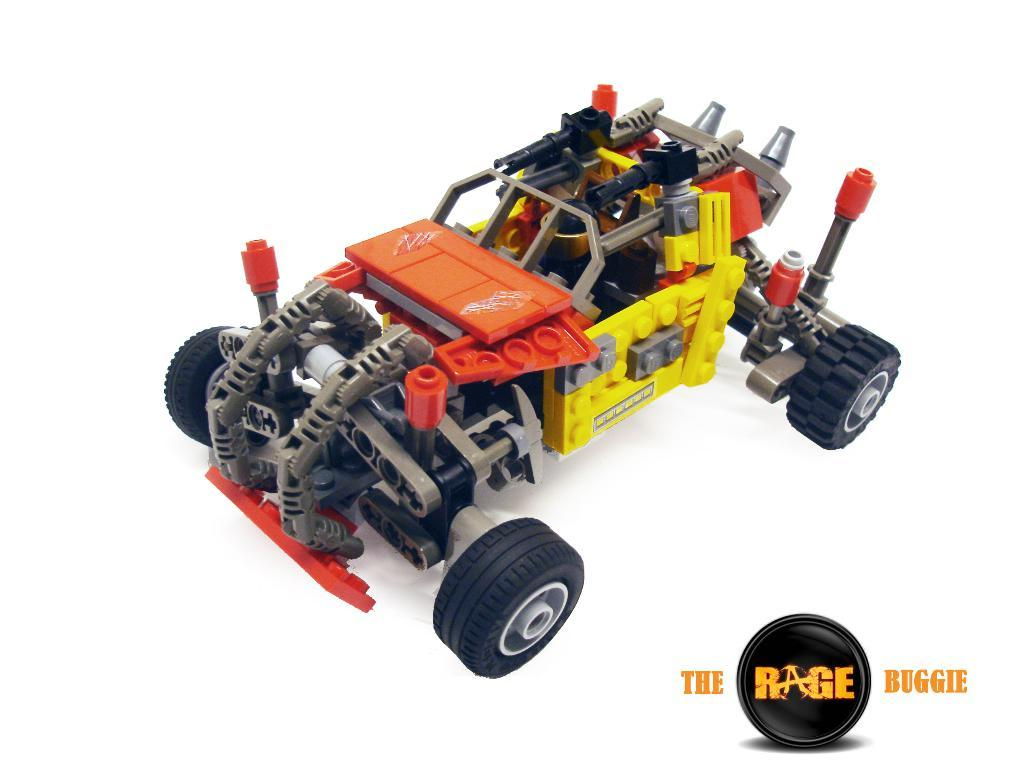What type of object is the main subject of the image? There is a toy vehicle in the image. Can you describe any text present in the image? Yes, there is text on the right side bottom of the image. How many flowers are growing on the island in the image? There is no island or flowers present in the image; it features a toy vehicle and text. 